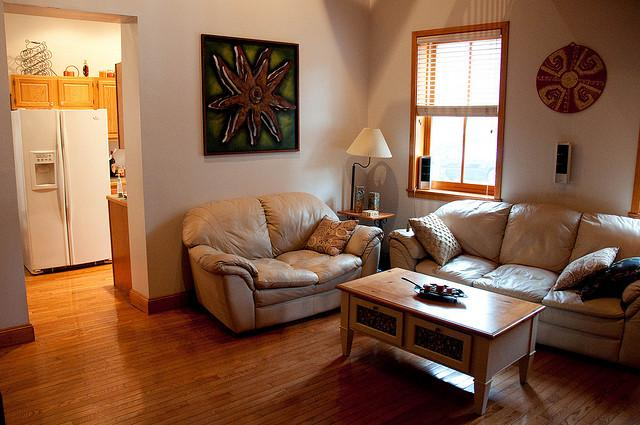What pair of devices are mounted on the wall and in the window sill? speakers 